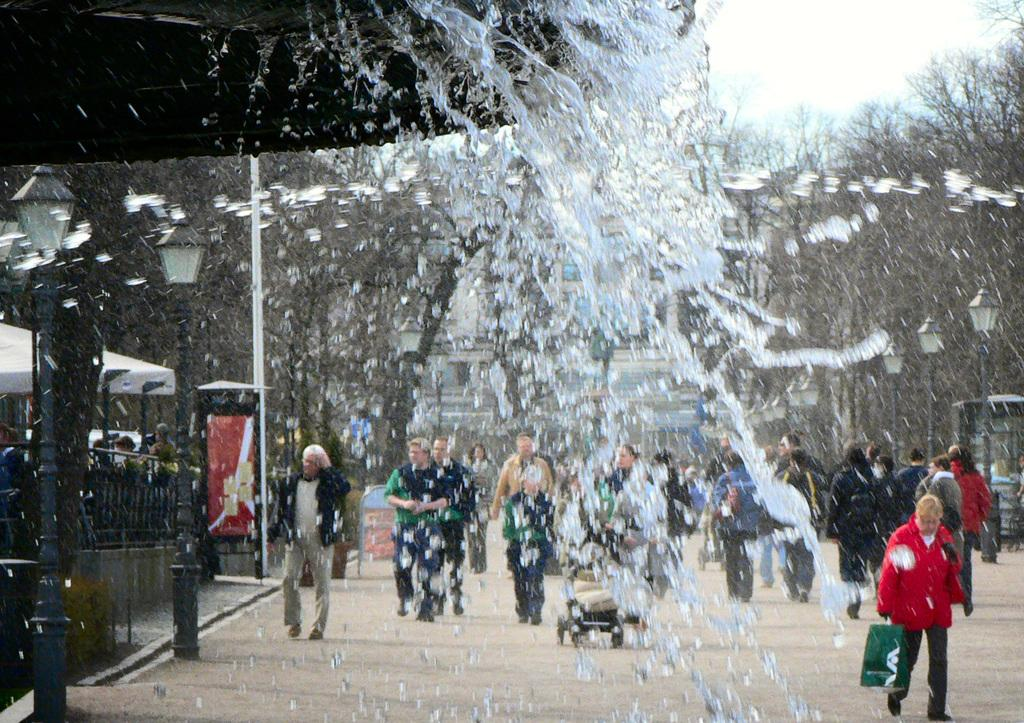What is happening with the water in the image? Water is spilling in the image. What can be seen on the road in the image? There is a group of people walking on the road. What type of vegetation is on the right side of the image? There are trees on the right side of the image. What type of lighting is present on the left side of the image? There are street lamps on the lamps on the left side of the image. What type of wire is being used by the zebra to cross the road in the image? There is no zebra present in the image, and therefore no wire or crossing activity can be observed. 